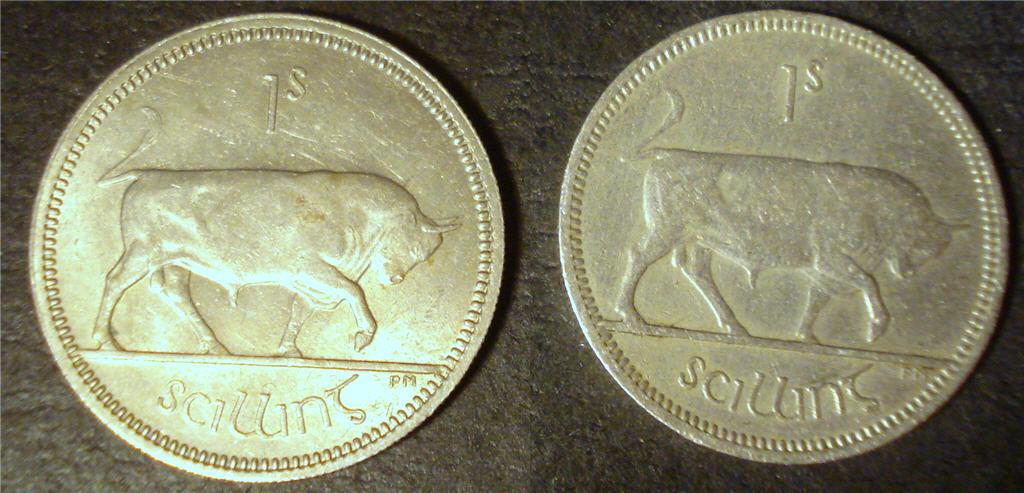<image>
Present a compact description of the photo's key features. two coins next to each other that say 1s and sciuins 